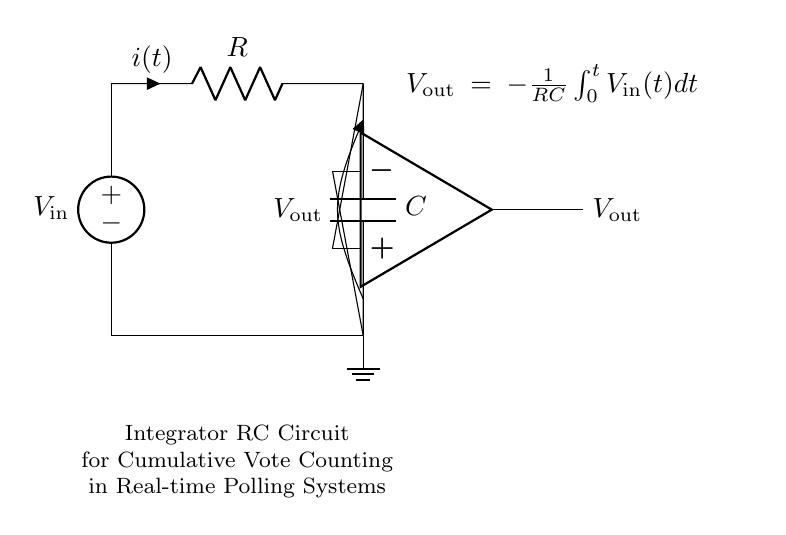What does the capacitor represent in this circuit? The capacitor in this circuit represents a means to store voltage over time and is crucial for integrating the input signal to produce a cumulative output.
Answer: Capacitor What is the role of the resistor in this circuit? The resistor limits the current flowing through the circuit and, together with the capacitor, determines the time constant, affecting how quickly the output voltage responds to changes in the input.
Answer: Resistor What is the output voltage equation displayed in the circuit? The equation described in the circuit is negative one divided by the product of resistance and capacitance times the integral of the input voltage from zero to time t.
Answer: Vout = -1/RC ∫Vin dt What happens to the output voltage if the input voltage is a constant value? If the input voltage is constant, the output voltage will continue to change linearly over time, driven by the constant voltage applied.
Answer: Ramps up linearly How can the output voltage be interpreted in terms of vote counting? The output voltage acts as a cumulative measure of the votes counted over time, integrating each input signal reflecting votes received in the polling system.
Answer: Cumulative votes What type of circuit is depicted in the diagram? The circuit depicted is an integrator circuit, which is designed specifically to integrate input signals over time, making it suitable for applications like cumulative vote counting.
Answer: Integrator circuit 